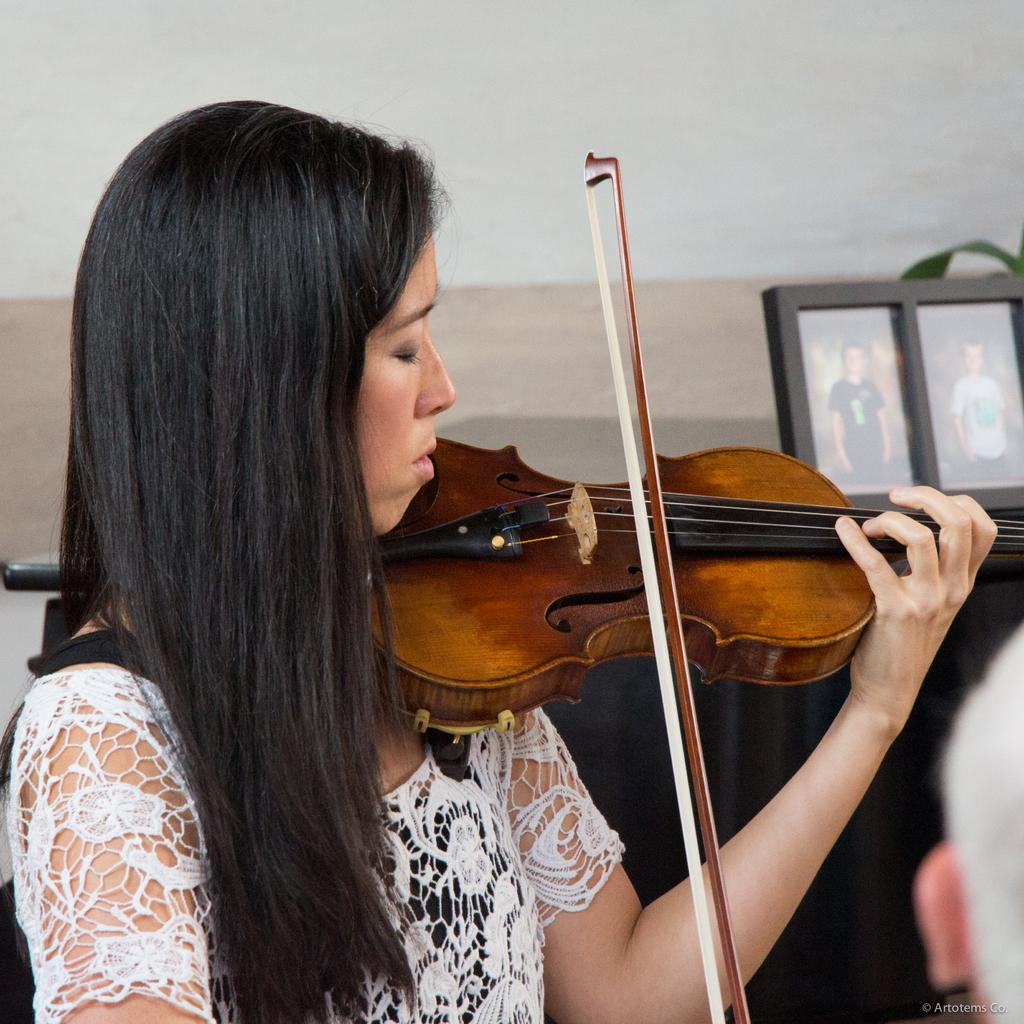Who is the main subject in the image? There is a woman in the middle of the image. What is the woman doing in the image? The woman is playing a violin. What can be seen in the background of the image? There are photo frames, a plant, and a wall in the background of the image. Is there any text present in the image? Yes, there is text at the bottom of the image. What type of wine is being served in the image? There is no wine present in the image; it features a woman playing a violin with a background that includes photo frames, a plant, and a wall. How many light bulbs are visible in the image? There are no light bulbs visible in the image. 